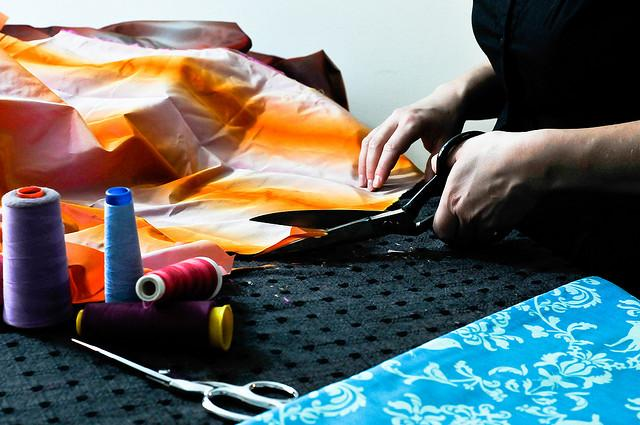What item does the person cut? fabric 